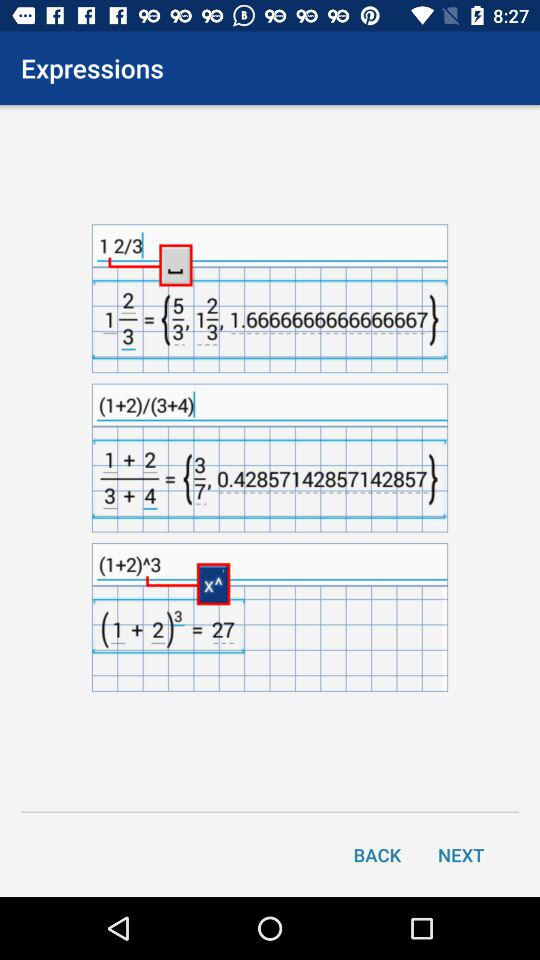What is the result of (1+2)3?
Answer the question using a single word or phrase. 27 